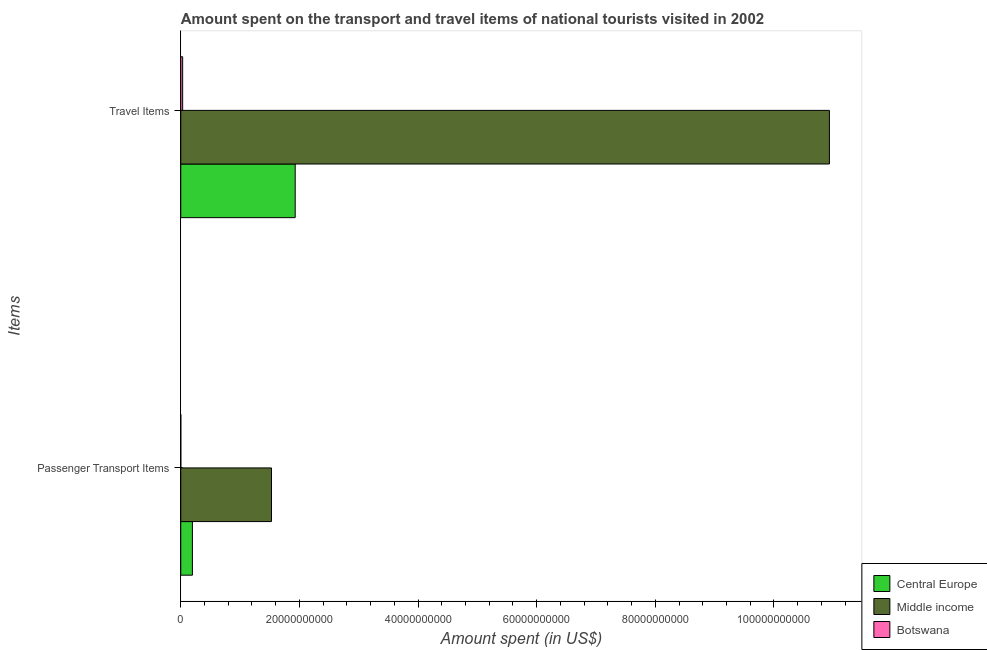Are the number of bars per tick equal to the number of legend labels?
Give a very brief answer. Yes. Are the number of bars on each tick of the Y-axis equal?
Keep it short and to the point. Yes. How many bars are there on the 1st tick from the top?
Provide a short and direct response. 3. How many bars are there on the 2nd tick from the bottom?
Offer a very short reply. 3. What is the label of the 1st group of bars from the top?
Give a very brief answer. Travel Items. What is the amount spent in travel items in Central Europe?
Give a very brief answer. 1.93e+1. Across all countries, what is the maximum amount spent on passenger transport items?
Keep it short and to the point. 1.53e+1. In which country was the amount spent on passenger transport items maximum?
Your response must be concise. Middle income. In which country was the amount spent in travel items minimum?
Make the answer very short. Botswana. What is the total amount spent in travel items in the graph?
Keep it short and to the point. 1.29e+11. What is the difference between the amount spent on passenger transport items in Middle income and that in Botswana?
Your answer should be very brief. 1.53e+1. What is the difference between the amount spent on passenger transport items in Botswana and the amount spent in travel items in Middle income?
Offer a terse response. -1.09e+11. What is the average amount spent on passenger transport items per country?
Make the answer very short. 5.75e+09. What is the difference between the amount spent on passenger transport items and amount spent in travel items in Central Europe?
Your answer should be very brief. -1.73e+1. In how many countries, is the amount spent on passenger transport items greater than 20000000000 US$?
Your answer should be compact. 0. What is the ratio of the amount spent on passenger transport items in Central Europe to that in Middle income?
Offer a terse response. 0.13. What does the 2nd bar from the top in Travel Items represents?
Offer a terse response. Middle income. What does the 3rd bar from the bottom in Passenger Transport Items represents?
Keep it short and to the point. Botswana. Are all the bars in the graph horizontal?
Your answer should be very brief. Yes. Does the graph contain any zero values?
Ensure brevity in your answer.  No. Does the graph contain grids?
Offer a terse response. No. Where does the legend appear in the graph?
Keep it short and to the point. Bottom right. How many legend labels are there?
Your answer should be compact. 3. How are the legend labels stacked?
Give a very brief answer. Vertical. What is the title of the graph?
Ensure brevity in your answer.  Amount spent on the transport and travel items of national tourists visited in 2002. Does "Faeroe Islands" appear as one of the legend labels in the graph?
Provide a succinct answer. No. What is the label or title of the X-axis?
Ensure brevity in your answer.  Amount spent (in US$). What is the label or title of the Y-axis?
Offer a very short reply. Items. What is the Amount spent (in US$) in Central Europe in Passenger Transport Items?
Offer a very short reply. 1.96e+09. What is the Amount spent (in US$) in Middle income in Passenger Transport Items?
Provide a short and direct response. 1.53e+1. What is the Amount spent (in US$) in Central Europe in Travel Items?
Ensure brevity in your answer.  1.93e+1. What is the Amount spent (in US$) in Middle income in Travel Items?
Offer a very short reply. 1.09e+11. What is the Amount spent (in US$) of Botswana in Travel Items?
Your answer should be compact. 3.19e+08. Across all Items, what is the maximum Amount spent (in US$) in Central Europe?
Your response must be concise. 1.93e+1. Across all Items, what is the maximum Amount spent (in US$) of Middle income?
Make the answer very short. 1.09e+11. Across all Items, what is the maximum Amount spent (in US$) in Botswana?
Give a very brief answer. 3.19e+08. Across all Items, what is the minimum Amount spent (in US$) in Central Europe?
Your response must be concise. 1.96e+09. Across all Items, what is the minimum Amount spent (in US$) of Middle income?
Give a very brief answer. 1.53e+1. Across all Items, what is the minimum Amount spent (in US$) in Botswana?
Provide a succinct answer. 5.00e+06. What is the total Amount spent (in US$) in Central Europe in the graph?
Ensure brevity in your answer.  2.13e+1. What is the total Amount spent (in US$) in Middle income in the graph?
Provide a succinct answer. 1.25e+11. What is the total Amount spent (in US$) of Botswana in the graph?
Provide a succinct answer. 3.24e+08. What is the difference between the Amount spent (in US$) in Central Europe in Passenger Transport Items and that in Travel Items?
Your answer should be very brief. -1.73e+1. What is the difference between the Amount spent (in US$) in Middle income in Passenger Transport Items and that in Travel Items?
Your answer should be very brief. -9.41e+1. What is the difference between the Amount spent (in US$) of Botswana in Passenger Transport Items and that in Travel Items?
Keep it short and to the point. -3.14e+08. What is the difference between the Amount spent (in US$) of Central Europe in Passenger Transport Items and the Amount spent (in US$) of Middle income in Travel Items?
Make the answer very short. -1.07e+11. What is the difference between the Amount spent (in US$) in Central Europe in Passenger Transport Items and the Amount spent (in US$) in Botswana in Travel Items?
Offer a very short reply. 1.64e+09. What is the difference between the Amount spent (in US$) in Middle income in Passenger Transport Items and the Amount spent (in US$) in Botswana in Travel Items?
Offer a terse response. 1.50e+1. What is the average Amount spent (in US$) of Central Europe per Items?
Offer a terse response. 1.06e+1. What is the average Amount spent (in US$) of Middle income per Items?
Your answer should be compact. 6.23e+1. What is the average Amount spent (in US$) of Botswana per Items?
Your answer should be compact. 1.62e+08. What is the difference between the Amount spent (in US$) of Central Europe and Amount spent (in US$) of Middle income in Passenger Transport Items?
Provide a succinct answer. -1.33e+1. What is the difference between the Amount spent (in US$) of Central Europe and Amount spent (in US$) of Botswana in Passenger Transport Items?
Offer a very short reply. 1.96e+09. What is the difference between the Amount spent (in US$) of Middle income and Amount spent (in US$) of Botswana in Passenger Transport Items?
Give a very brief answer. 1.53e+1. What is the difference between the Amount spent (in US$) of Central Europe and Amount spent (in US$) of Middle income in Travel Items?
Provide a succinct answer. -9.01e+1. What is the difference between the Amount spent (in US$) in Central Europe and Amount spent (in US$) in Botswana in Travel Items?
Give a very brief answer. 1.90e+1. What is the difference between the Amount spent (in US$) in Middle income and Amount spent (in US$) in Botswana in Travel Items?
Your response must be concise. 1.09e+11. What is the ratio of the Amount spent (in US$) of Central Europe in Passenger Transport Items to that in Travel Items?
Give a very brief answer. 0.1. What is the ratio of the Amount spent (in US$) of Middle income in Passenger Transport Items to that in Travel Items?
Your answer should be compact. 0.14. What is the ratio of the Amount spent (in US$) of Botswana in Passenger Transport Items to that in Travel Items?
Offer a terse response. 0.02. What is the difference between the highest and the second highest Amount spent (in US$) of Central Europe?
Keep it short and to the point. 1.73e+1. What is the difference between the highest and the second highest Amount spent (in US$) of Middle income?
Provide a short and direct response. 9.41e+1. What is the difference between the highest and the second highest Amount spent (in US$) in Botswana?
Provide a succinct answer. 3.14e+08. What is the difference between the highest and the lowest Amount spent (in US$) in Central Europe?
Make the answer very short. 1.73e+1. What is the difference between the highest and the lowest Amount spent (in US$) in Middle income?
Offer a very short reply. 9.41e+1. What is the difference between the highest and the lowest Amount spent (in US$) in Botswana?
Provide a succinct answer. 3.14e+08. 